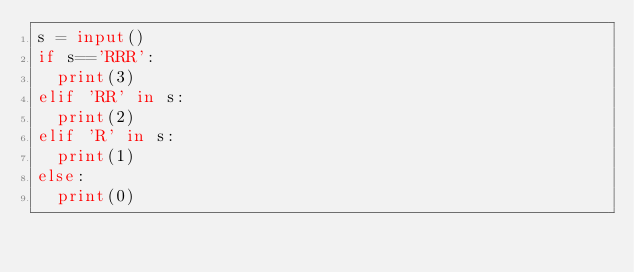<code> <loc_0><loc_0><loc_500><loc_500><_Python_>s = input()
if s=='RRR':
  print(3)
elif 'RR' in s:
  print(2)
elif 'R' in s:
  print(1)
else:
  print(0)</code> 